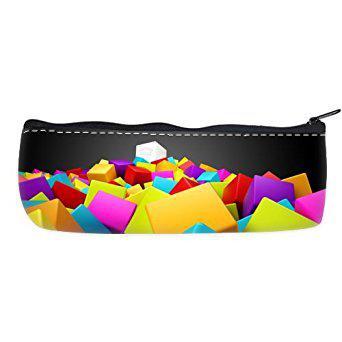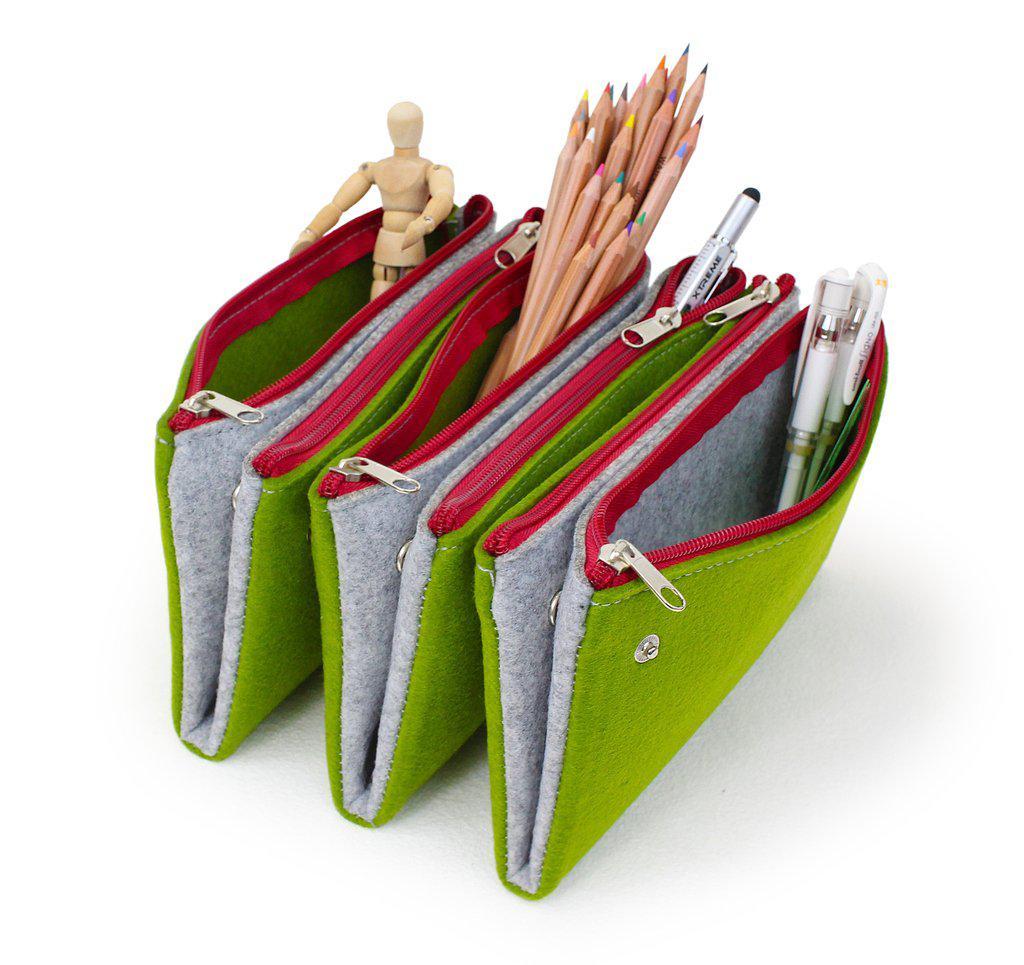The first image is the image on the left, the second image is the image on the right. Evaluate the accuracy of this statement regarding the images: "An image contains at least one green pencil bag with a red zipper.". Is it true? Answer yes or no. Yes. 